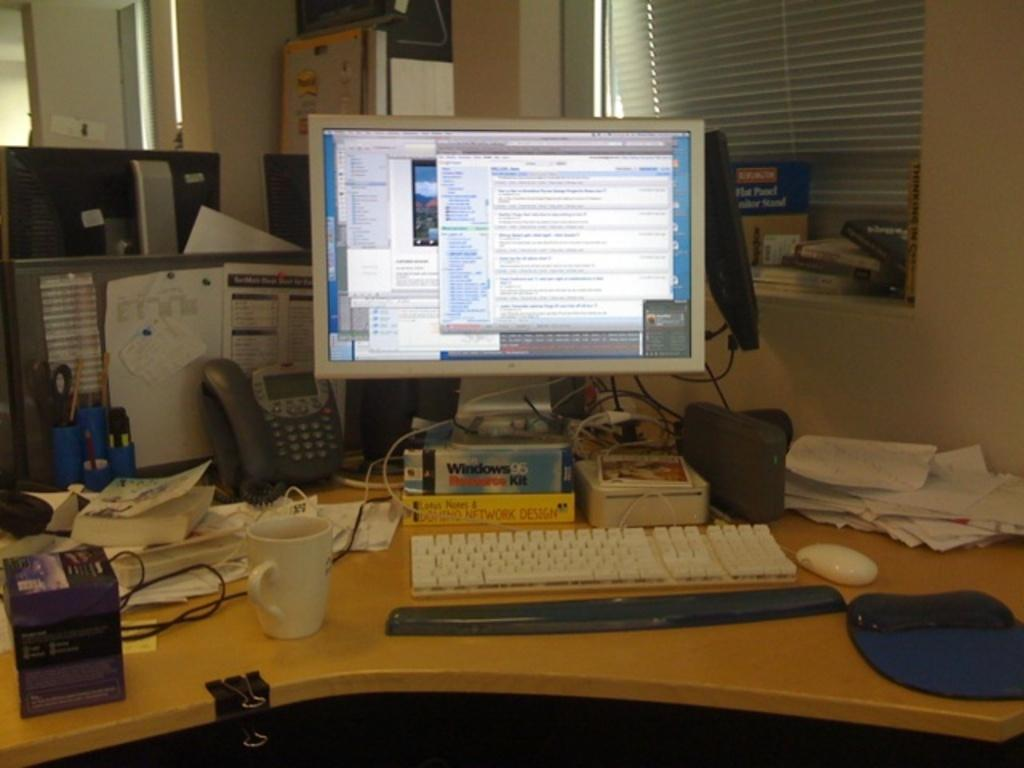What electronic device is on the table in the image? There is a computer on a table in the image. What is connected to the computer? The computer has a cable. What is used to control the computer? The computer has a mouse. What items can be seen behind the table? There are papers, books, a glass, and a phone behind the table. What type of waves can be seen crashing on the shore in the image? There are no waves or shore visible in the image; it features a computer on a table with items behind it. 